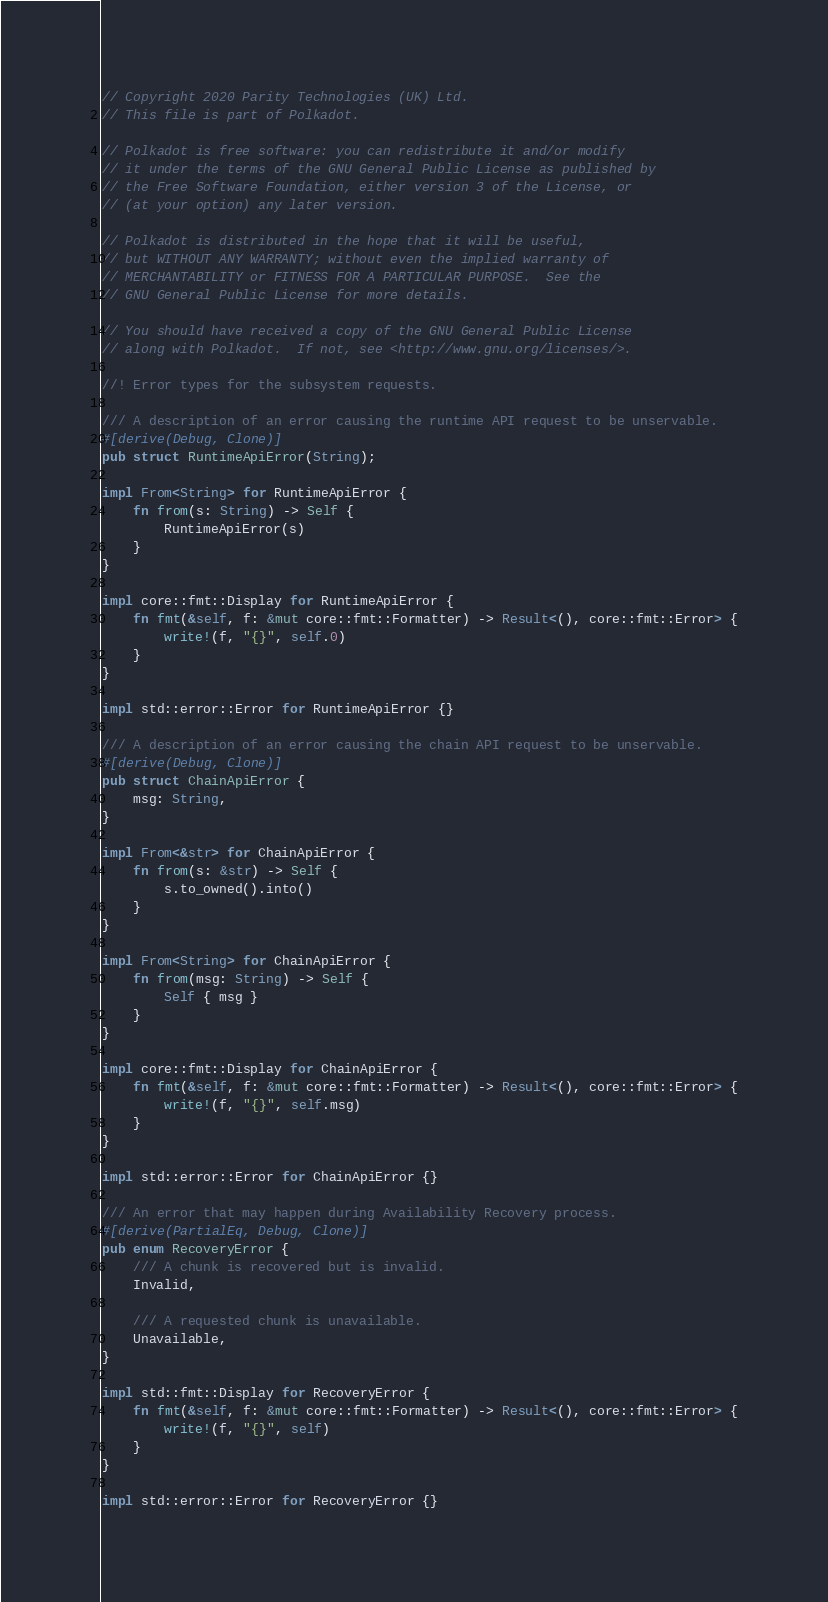<code> <loc_0><loc_0><loc_500><loc_500><_Rust_>// Copyright 2020 Parity Technologies (UK) Ltd.
// This file is part of Polkadot.

// Polkadot is free software: you can redistribute it and/or modify
// it under the terms of the GNU General Public License as published by
// the Free Software Foundation, either version 3 of the License, or
// (at your option) any later version.

// Polkadot is distributed in the hope that it will be useful,
// but WITHOUT ANY WARRANTY; without even the implied warranty of
// MERCHANTABILITY or FITNESS FOR A PARTICULAR PURPOSE.  See the
// GNU General Public License for more details.

// You should have received a copy of the GNU General Public License
// along with Polkadot.  If not, see <http://www.gnu.org/licenses/>.

//! Error types for the subsystem requests.

/// A description of an error causing the runtime API request to be unservable.
#[derive(Debug, Clone)]
pub struct RuntimeApiError(String);

impl From<String> for RuntimeApiError {
	fn from(s: String) -> Self {
		RuntimeApiError(s)
	}
}

impl core::fmt::Display for RuntimeApiError {
	fn fmt(&self, f: &mut core::fmt::Formatter) -> Result<(), core::fmt::Error> {
		write!(f, "{}", self.0)
	}
}

impl std::error::Error for RuntimeApiError {}

/// A description of an error causing the chain API request to be unservable.
#[derive(Debug, Clone)]
pub struct ChainApiError {
	msg: String,
}

impl From<&str> for ChainApiError {
	fn from(s: &str) -> Self {
		s.to_owned().into()
	}
}

impl From<String> for ChainApiError {
	fn from(msg: String) -> Self {
		Self { msg }
	}
}

impl core::fmt::Display for ChainApiError {
	fn fmt(&self, f: &mut core::fmt::Formatter) -> Result<(), core::fmt::Error> {
		write!(f, "{}", self.msg)
	}
}

impl std::error::Error for ChainApiError {}

/// An error that may happen during Availability Recovery process.
#[derive(PartialEq, Debug, Clone)]
pub enum RecoveryError {
	/// A chunk is recovered but is invalid.
	Invalid,

	/// A requested chunk is unavailable.
	Unavailable,
}

impl std::fmt::Display for RecoveryError {
	fn fmt(&self, f: &mut core::fmt::Formatter) -> Result<(), core::fmt::Error> {
		write!(f, "{}", self)
	}
}

impl std::error::Error for RecoveryError {}
</code> 